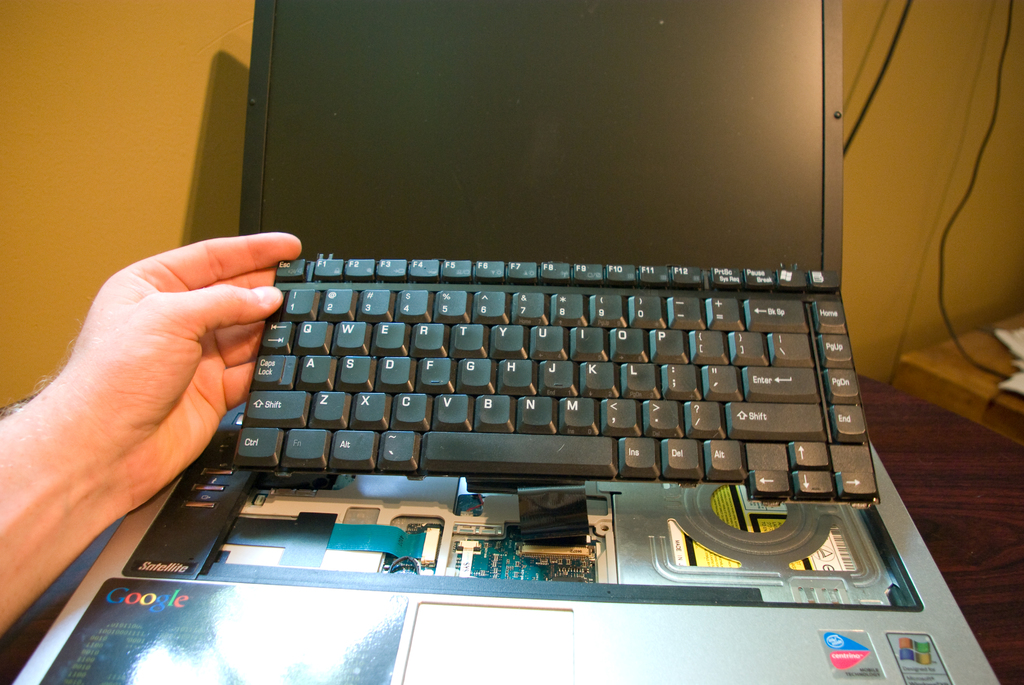Could you explain how disassembling a laptop like this might affect its warranty? Disassembling a laptop can often void the manufacturer's warranty, especially if it's done without professional guidance. It's important to check the warranty terms before opening up the device. 